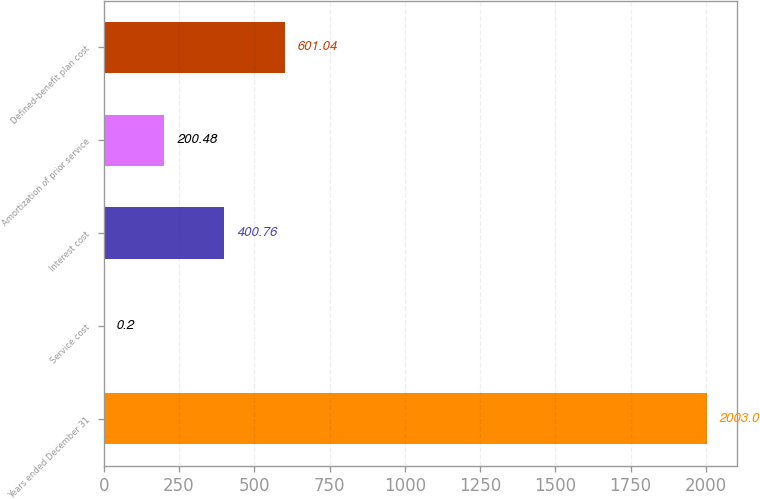<chart> <loc_0><loc_0><loc_500><loc_500><bar_chart><fcel>Years ended December 31<fcel>Service cost<fcel>Interest cost<fcel>Amortization of prior service<fcel>Defined-benefit plan cost<nl><fcel>2003<fcel>0.2<fcel>400.76<fcel>200.48<fcel>601.04<nl></chart> 